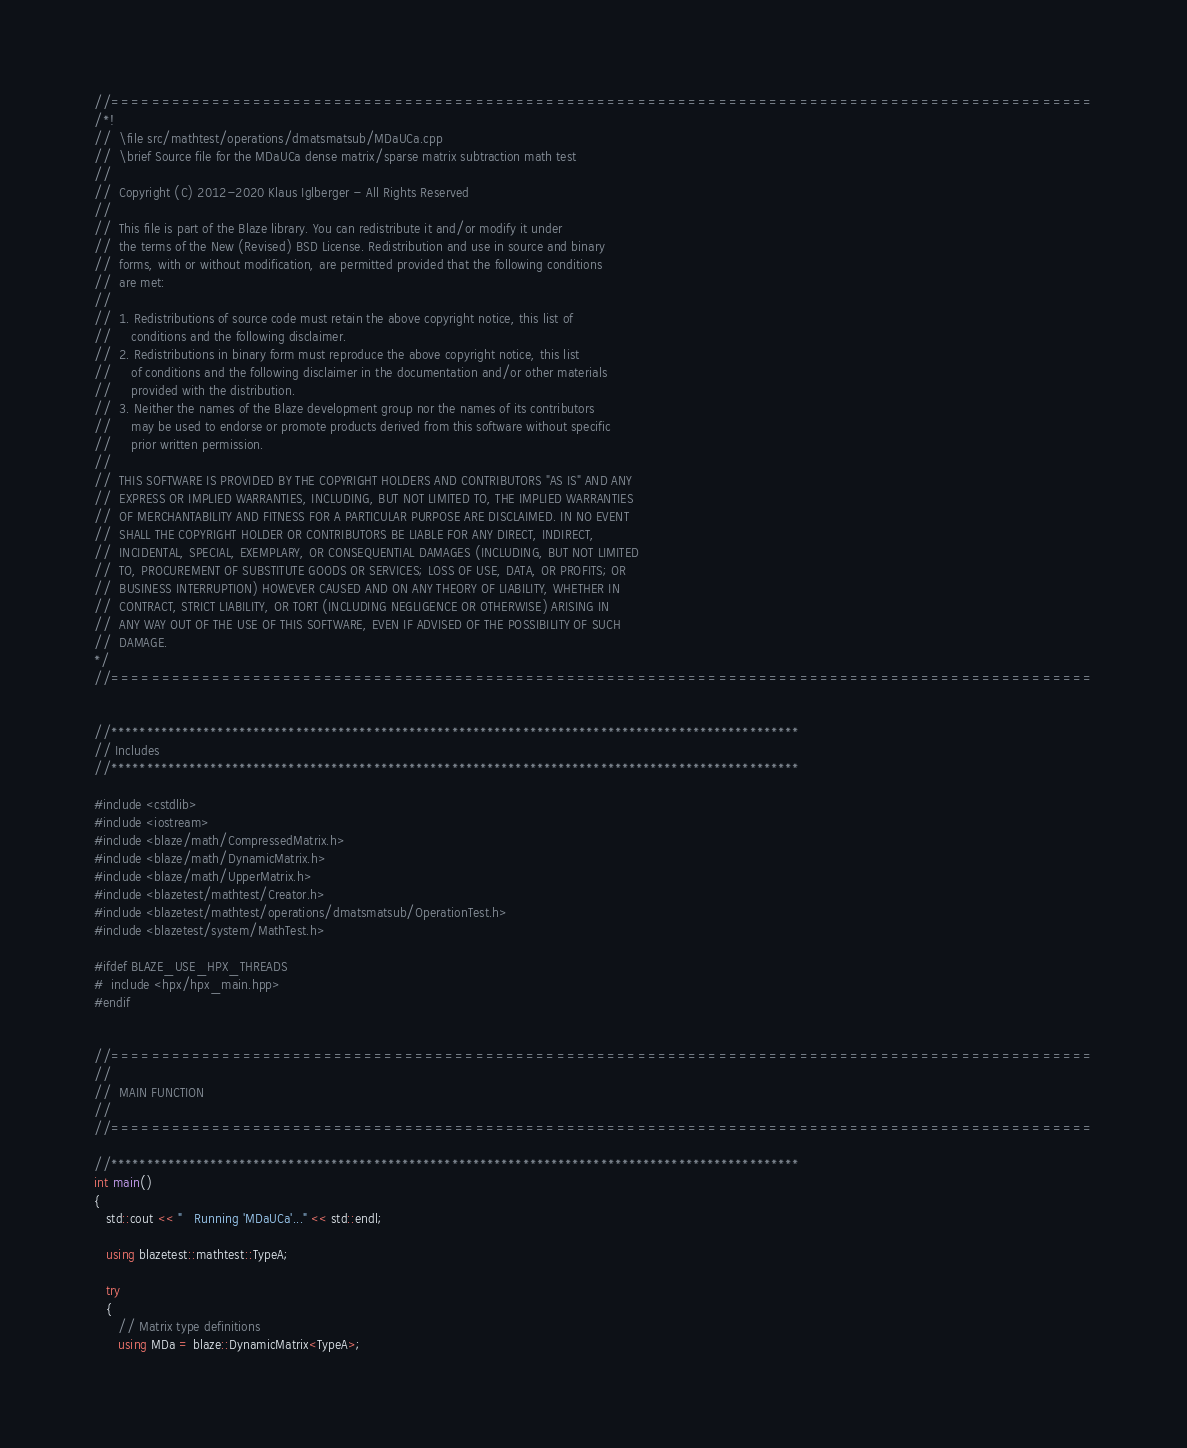Convert code to text. <code><loc_0><loc_0><loc_500><loc_500><_C++_>//=================================================================================================
/*!
//  \file src/mathtest/operations/dmatsmatsub/MDaUCa.cpp
//  \brief Source file for the MDaUCa dense matrix/sparse matrix subtraction math test
//
//  Copyright (C) 2012-2020 Klaus Iglberger - All Rights Reserved
//
//  This file is part of the Blaze library. You can redistribute it and/or modify it under
//  the terms of the New (Revised) BSD License. Redistribution and use in source and binary
//  forms, with or without modification, are permitted provided that the following conditions
//  are met:
//
//  1. Redistributions of source code must retain the above copyright notice, this list of
//     conditions and the following disclaimer.
//  2. Redistributions in binary form must reproduce the above copyright notice, this list
//     of conditions and the following disclaimer in the documentation and/or other materials
//     provided with the distribution.
//  3. Neither the names of the Blaze development group nor the names of its contributors
//     may be used to endorse or promote products derived from this software without specific
//     prior written permission.
//
//  THIS SOFTWARE IS PROVIDED BY THE COPYRIGHT HOLDERS AND CONTRIBUTORS "AS IS" AND ANY
//  EXPRESS OR IMPLIED WARRANTIES, INCLUDING, BUT NOT LIMITED TO, THE IMPLIED WARRANTIES
//  OF MERCHANTABILITY AND FITNESS FOR A PARTICULAR PURPOSE ARE DISCLAIMED. IN NO EVENT
//  SHALL THE COPYRIGHT HOLDER OR CONTRIBUTORS BE LIABLE FOR ANY DIRECT, INDIRECT,
//  INCIDENTAL, SPECIAL, EXEMPLARY, OR CONSEQUENTIAL DAMAGES (INCLUDING, BUT NOT LIMITED
//  TO, PROCUREMENT OF SUBSTITUTE GOODS OR SERVICES; LOSS OF USE, DATA, OR PROFITS; OR
//  BUSINESS INTERRUPTION) HOWEVER CAUSED AND ON ANY THEORY OF LIABILITY, WHETHER IN
//  CONTRACT, STRICT LIABILITY, OR TORT (INCLUDING NEGLIGENCE OR OTHERWISE) ARISING IN
//  ANY WAY OUT OF THE USE OF THIS SOFTWARE, EVEN IF ADVISED OF THE POSSIBILITY OF SUCH
//  DAMAGE.
*/
//=================================================================================================


//*************************************************************************************************
// Includes
//*************************************************************************************************

#include <cstdlib>
#include <iostream>
#include <blaze/math/CompressedMatrix.h>
#include <blaze/math/DynamicMatrix.h>
#include <blaze/math/UpperMatrix.h>
#include <blazetest/mathtest/Creator.h>
#include <blazetest/mathtest/operations/dmatsmatsub/OperationTest.h>
#include <blazetest/system/MathTest.h>

#ifdef BLAZE_USE_HPX_THREADS
#  include <hpx/hpx_main.hpp>
#endif


//=================================================================================================
//
//  MAIN FUNCTION
//
//=================================================================================================

//*************************************************************************************************
int main()
{
   std::cout << "   Running 'MDaUCa'..." << std::endl;

   using blazetest::mathtest::TypeA;

   try
   {
      // Matrix type definitions
      using MDa = blaze::DynamicMatrix<TypeA>;</code> 